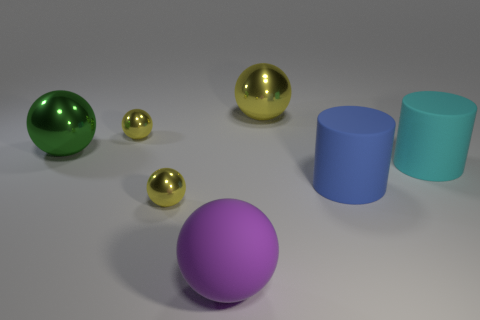How big is the yellow object that is both to the left of the purple thing and behind the large cyan rubber cylinder?
Offer a terse response. Small. What is the size of the other object that is the same shape as the big cyan matte thing?
Ensure brevity in your answer.  Large. What number of things are cyan metal spheres or balls that are in front of the blue object?
Your answer should be very brief. 2. What is the shape of the big blue object?
Your answer should be very brief. Cylinder. The yellow thing on the right side of the large matte thing on the left side of the large yellow thing is what shape?
Offer a very short reply. Sphere. What color is the ball that is the same material as the big cyan object?
Make the answer very short. Purple. Is there any other thing that has the same size as the matte sphere?
Ensure brevity in your answer.  Yes. There is a small sphere in front of the large green sphere; does it have the same color as the big sphere on the right side of the large purple rubber object?
Your response must be concise. Yes. Is the number of big rubber cylinders that are in front of the big matte sphere greater than the number of matte balls in front of the cyan cylinder?
Ensure brevity in your answer.  No. What color is the other matte thing that is the same shape as the blue object?
Offer a very short reply. Cyan. 